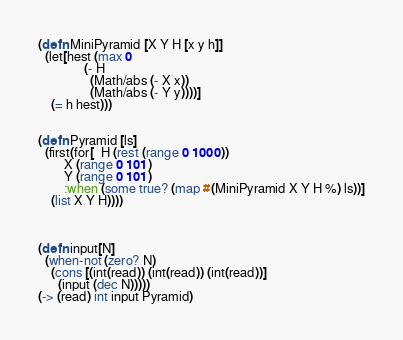Convert code to text. <code><loc_0><loc_0><loc_500><loc_500><_Clojure_>(defn MiniPyramid [X Y H [x y h]]
  (let[hest (max 0 
              (- H 
                (Math/abs (- X x)) 
                (Math/abs (- Y y))))]
    (= h hest)))
              

(defn Pyramid [ls]
  (first(for[  H (rest (range 0 1000))
        X (range 0 101) 
        Y (range 0 101)
        :when (some true? (map #(MiniPyramid X Y H %) ls))]
    (list X Y H))))



(defn input[N]
  (when-not (zero? N)
    (cons [(int(read)) (int(read)) (int(read))]      
      (input (dec N)))))
(-> (read) int input Pyramid)</code> 